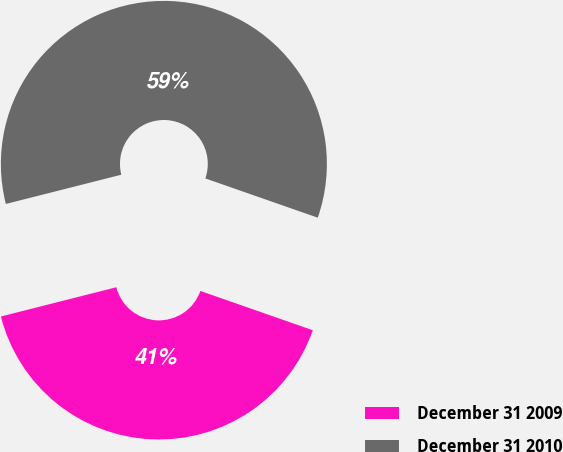<chart> <loc_0><loc_0><loc_500><loc_500><pie_chart><fcel>December 31 2009<fcel>December 31 2010<nl><fcel>40.7%<fcel>59.3%<nl></chart> 